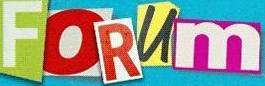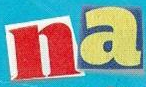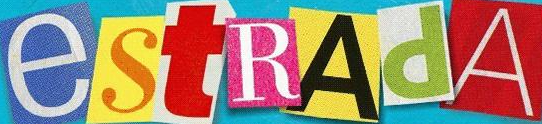Transcribe the words shown in these images in order, separated by a semicolon. FORUm; na; estRAdA 